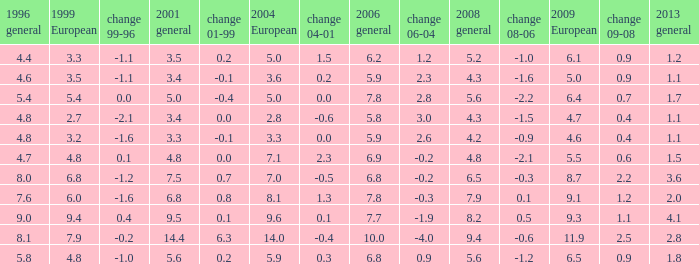How many values for 1999 European correspond to a value more than 4.7 in 2009 European, general 2001 more than 7.5, 2006 general at 10, and more than 9.4 in general 2008? 0.0. 